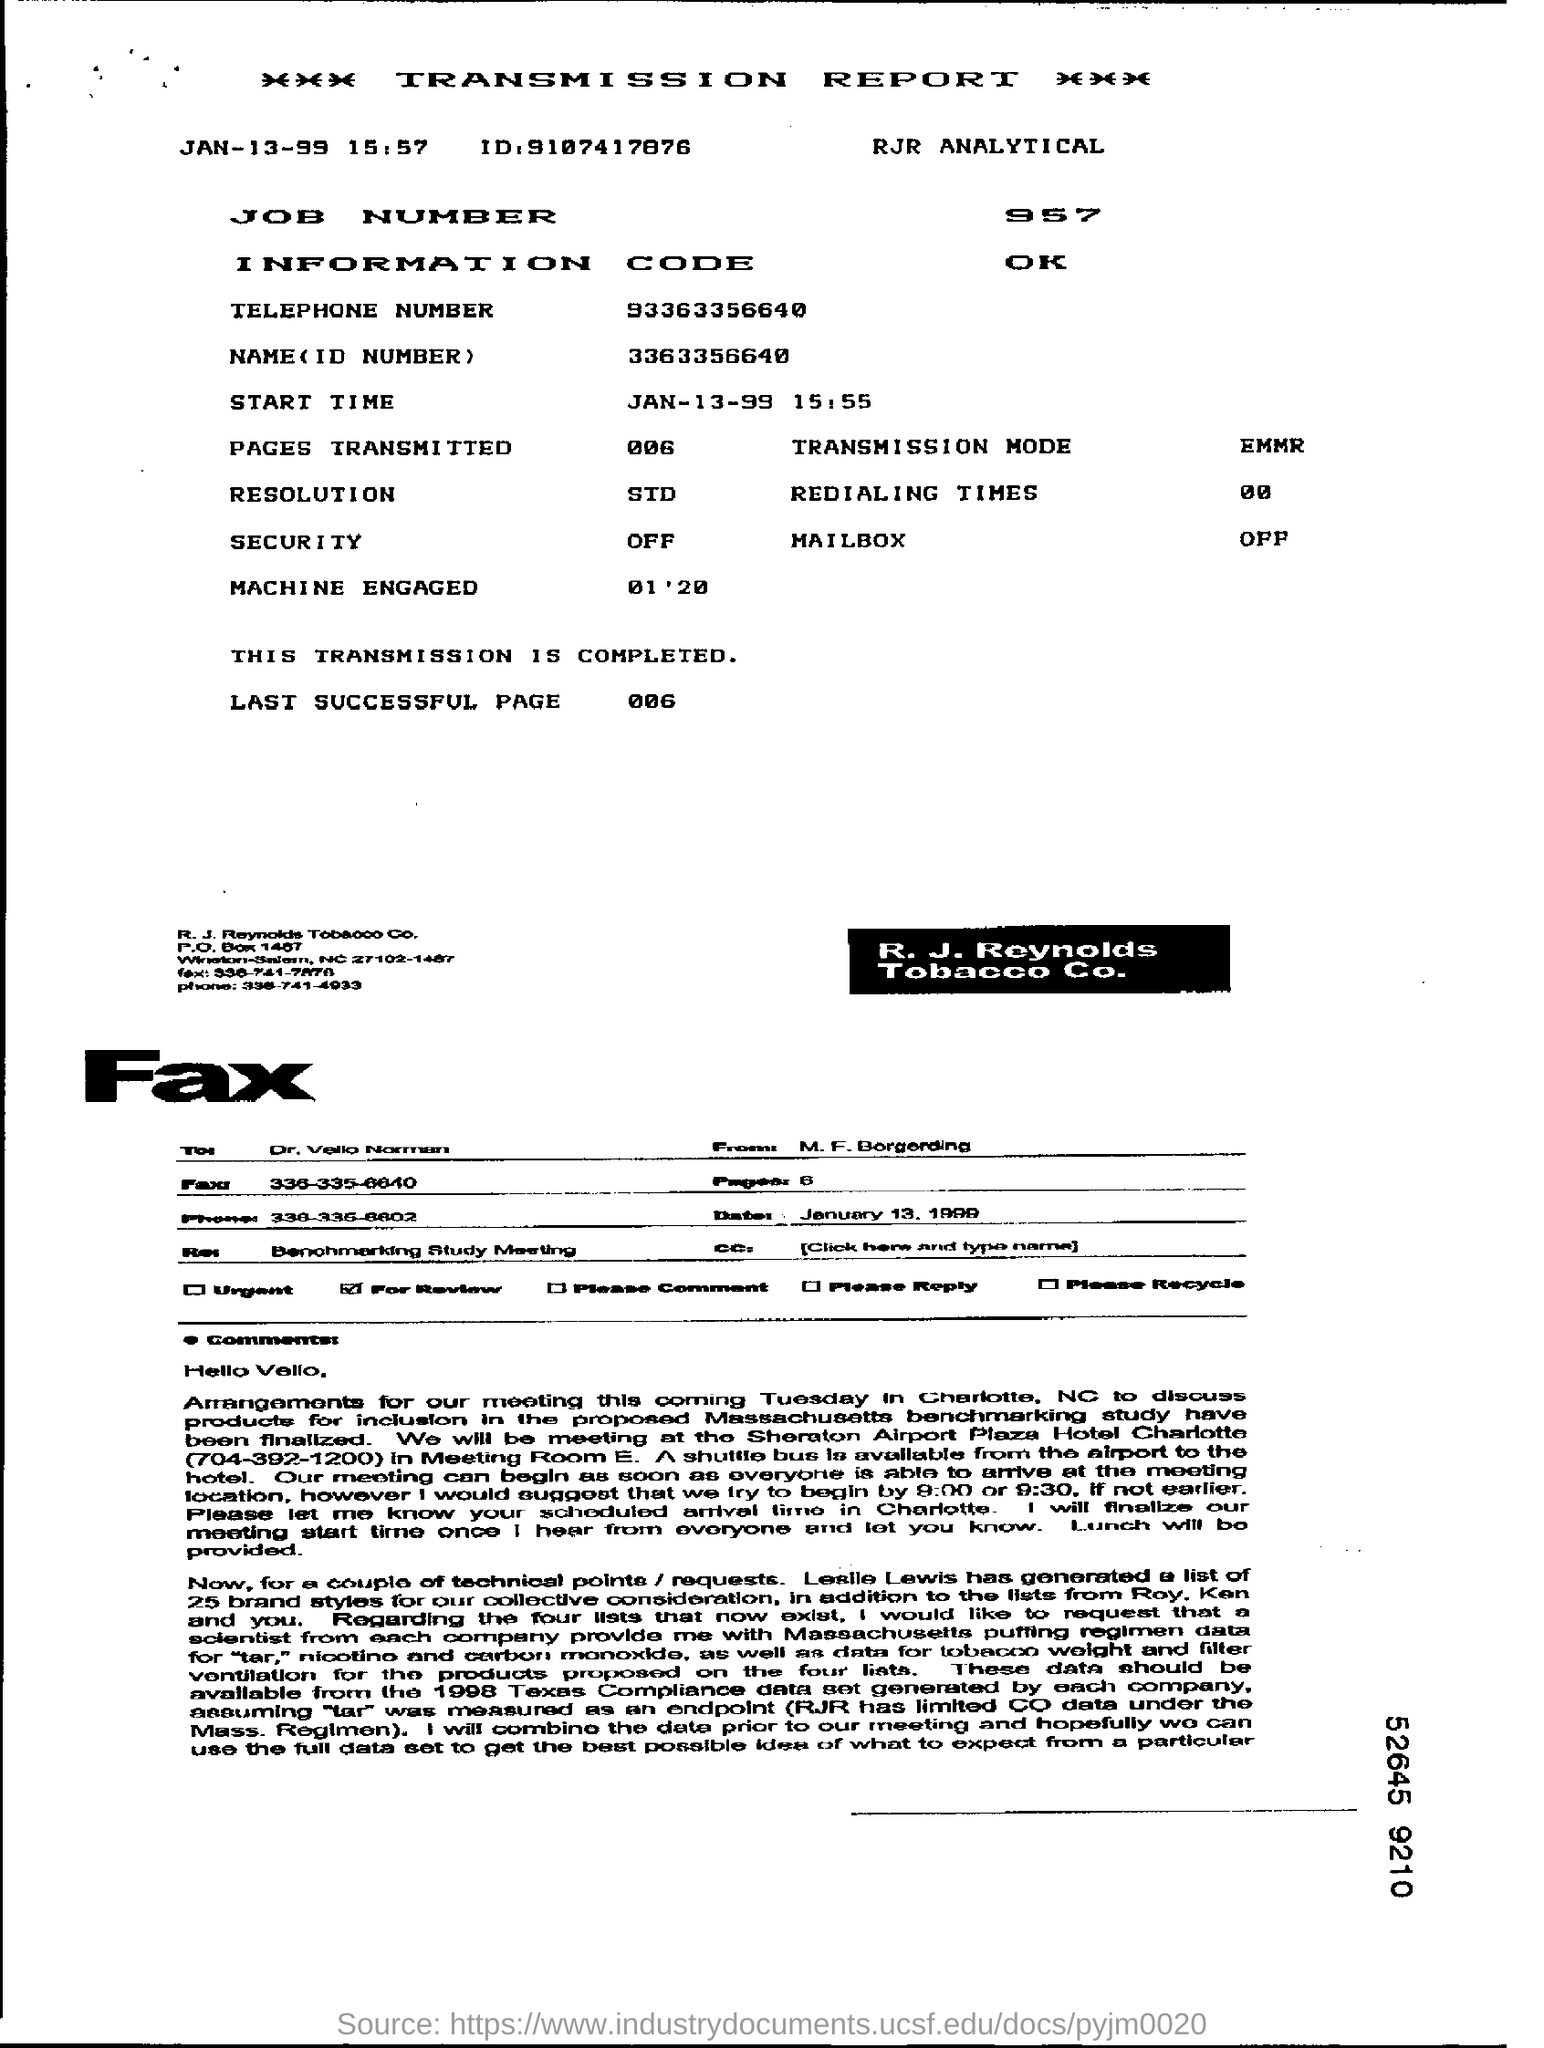Mention a couple of crucial points in this snapshot. The resolution is the final outcome or decision reached by a group or organization. It is often referred to as a "resolution" in the context of a legislative body, such as a congress or parliament, where a resolution is a formal written document proposing a course of action or expressing a opinion on a particular issue. What is the name corresponding to the ID number 3363356640? The telephone number is 93363356640. The job number is 957. The transmission mode is Ethernet, Mbps. 